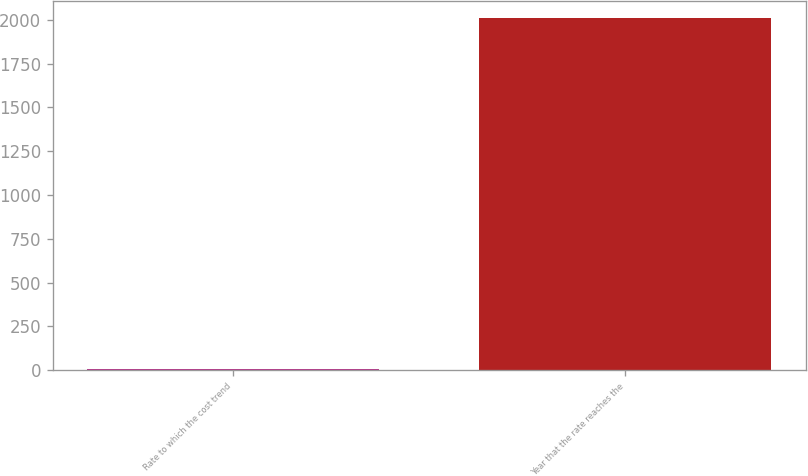Convert chart to OTSL. <chart><loc_0><loc_0><loc_500><loc_500><bar_chart><fcel>Rate to which the cost trend<fcel>Year that the rate reaches the<nl><fcel>5<fcel>2009<nl></chart> 